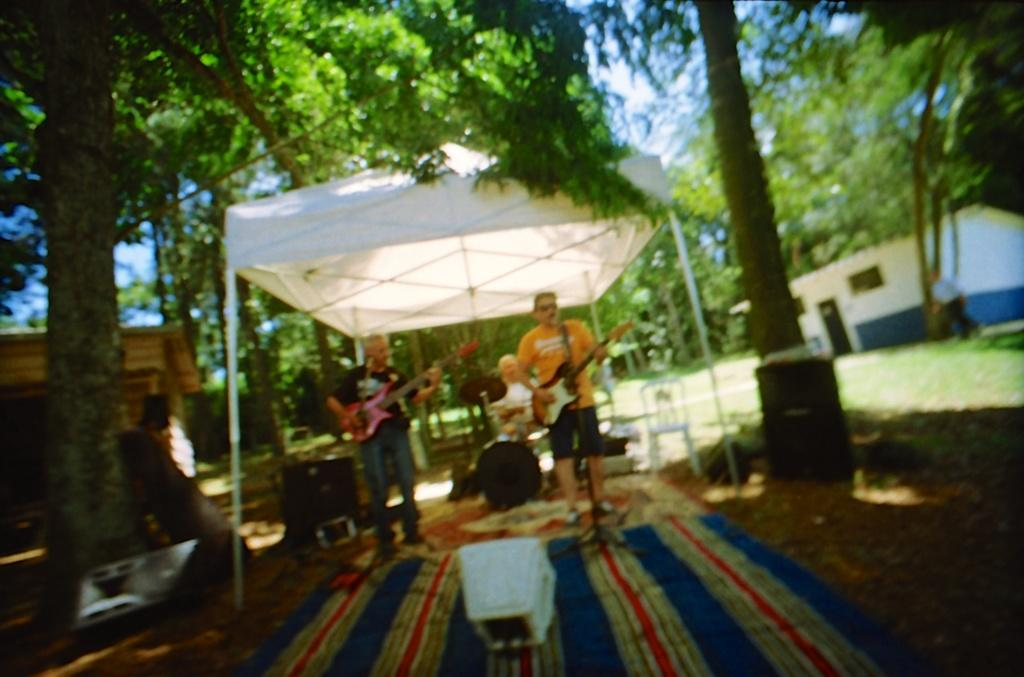How many persons are playing musical instruments in the image? There are three persons playing musical instruments in the image. What structure can be seen in the image? There is a tent in the image. What material is present in the image? There is cloth and grass in the image. What electronic device is visible in the image? There is a device in the image. What can be seen in the background of the image? There are houses, trees, and the sky visible in the background of the image. How many ants are crawling on the device in the image? There are no ants present in the image; only the device, musical instruments, tent, cloth, grass, houses, trees, and sky are visible. What is the value of the expansion in the image? There is no expansion present in the image, so it is not possible to determine its value. 